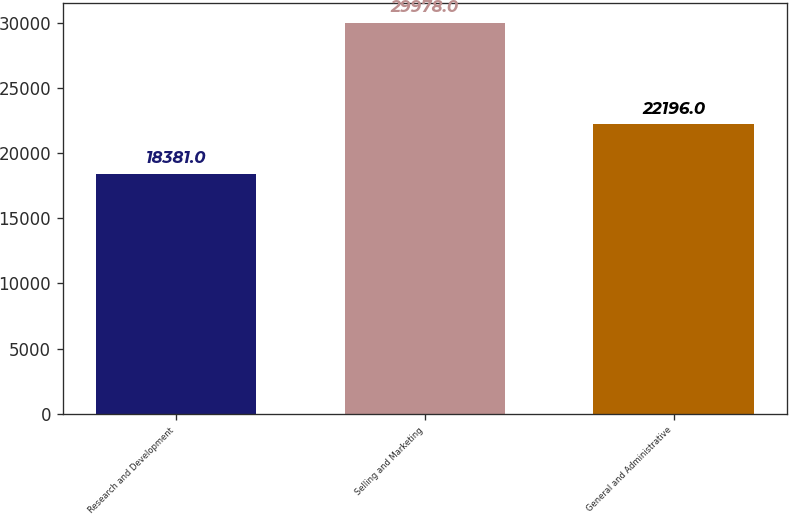Convert chart to OTSL. <chart><loc_0><loc_0><loc_500><loc_500><bar_chart><fcel>Research and Development<fcel>Selling and Marketing<fcel>General and Administrative<nl><fcel>18381<fcel>29978<fcel>22196<nl></chart> 